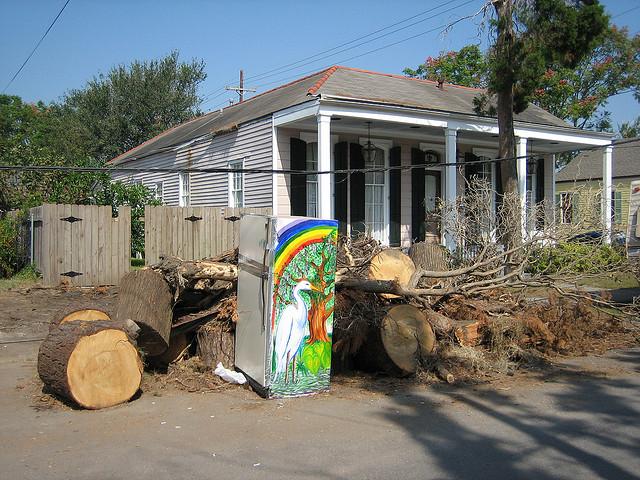Did someone cut the tree?
Quick response, please. Yes. What did they paint on the refrigerator?
Answer briefly. Bird, tree, rainbow. What kind of roof is on the house?
Write a very short answer. Shingles. 